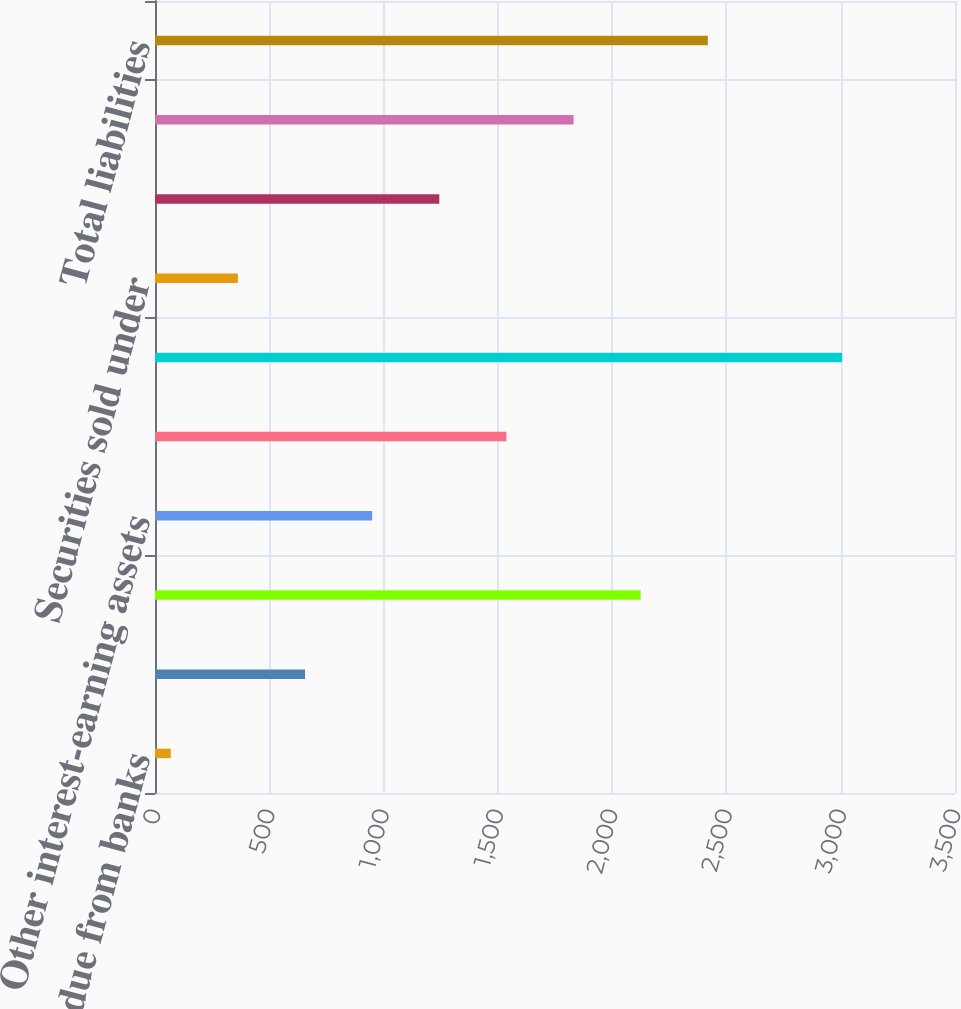Convert chart. <chart><loc_0><loc_0><loc_500><loc_500><bar_chart><fcel>Cash and due from banks<fcel>Securities purchased under<fcel>Trading account assets<fcel>Other interest-earning assets<fcel>Other assets<fcel>Total assets<fcel>Securities sold under<fcel>Other short-term borrowings<fcel>Other liabilities<fcel>Total liabilities<nl><fcel>69<fcel>656.4<fcel>2124.9<fcel>950.1<fcel>1537.5<fcel>3006<fcel>362.7<fcel>1243.8<fcel>1831.2<fcel>2418.6<nl></chart> 